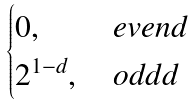<formula> <loc_0><loc_0><loc_500><loc_500>\begin{cases} 0 , & \, e v e n d \, \\ 2 ^ { 1 - d } , & \, o d d d \, \\ \end{cases}</formula> 